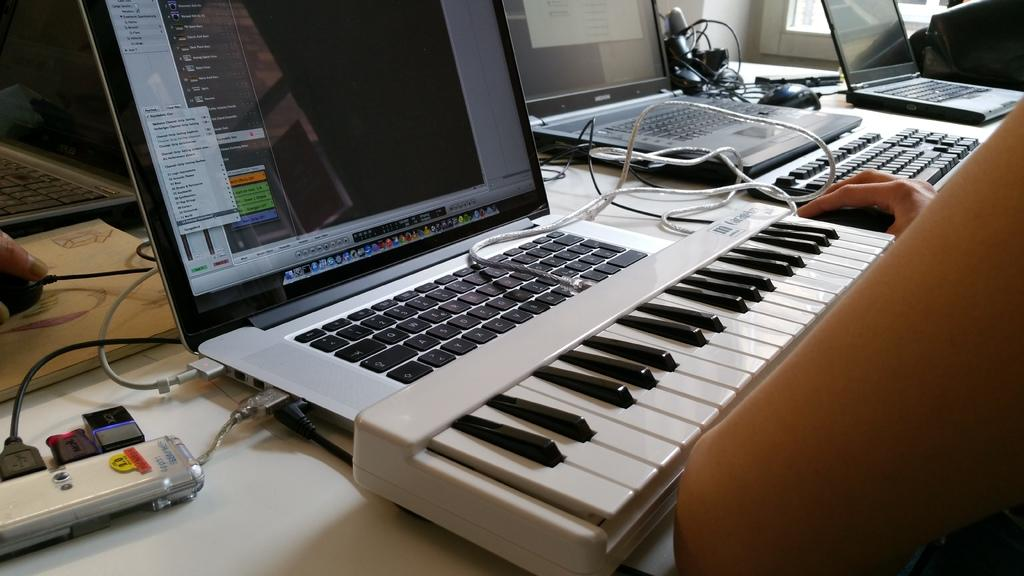What electronic device is visible in the image? There is a laptop in the image. What color is the laptop? The laptop is black in color. What type of insect can be seen crawling on the notebook in the image? There is no notebook or insect present in the image; it only features a black laptop. 